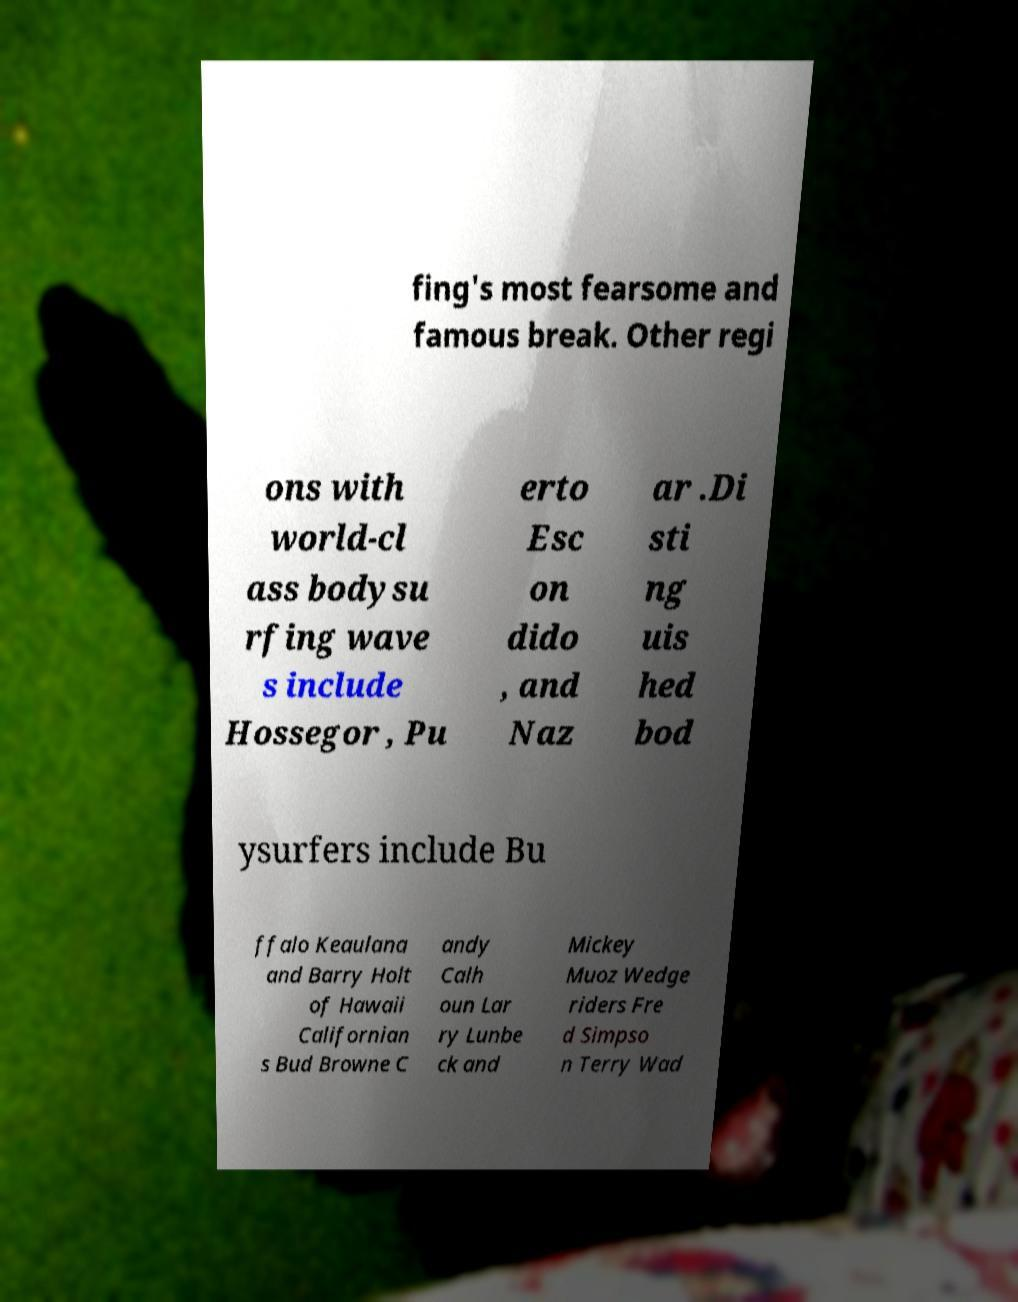Could you assist in decoding the text presented in this image and type it out clearly? fing's most fearsome and famous break. Other regi ons with world-cl ass bodysu rfing wave s include Hossegor , Pu erto Esc on dido , and Naz ar .Di sti ng uis hed bod ysurfers include Bu ffalo Keaulana and Barry Holt of Hawaii Californian s Bud Browne C andy Calh oun Lar ry Lunbe ck and Mickey Muoz Wedge riders Fre d Simpso n Terry Wad 